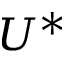<formula> <loc_0><loc_0><loc_500><loc_500>U ^ { * }</formula> 